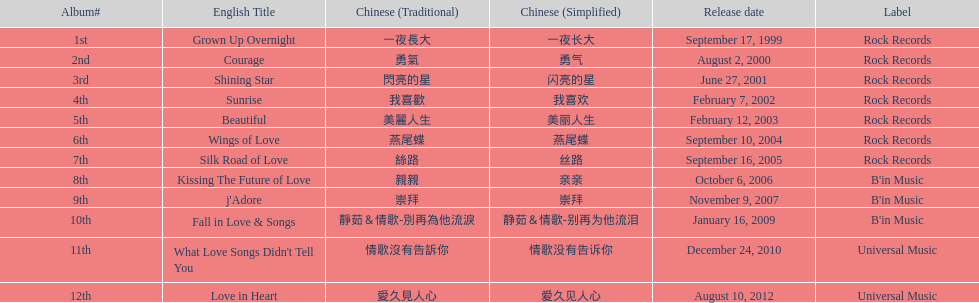Was beautiful launched prior to love in heart album? Yes. 